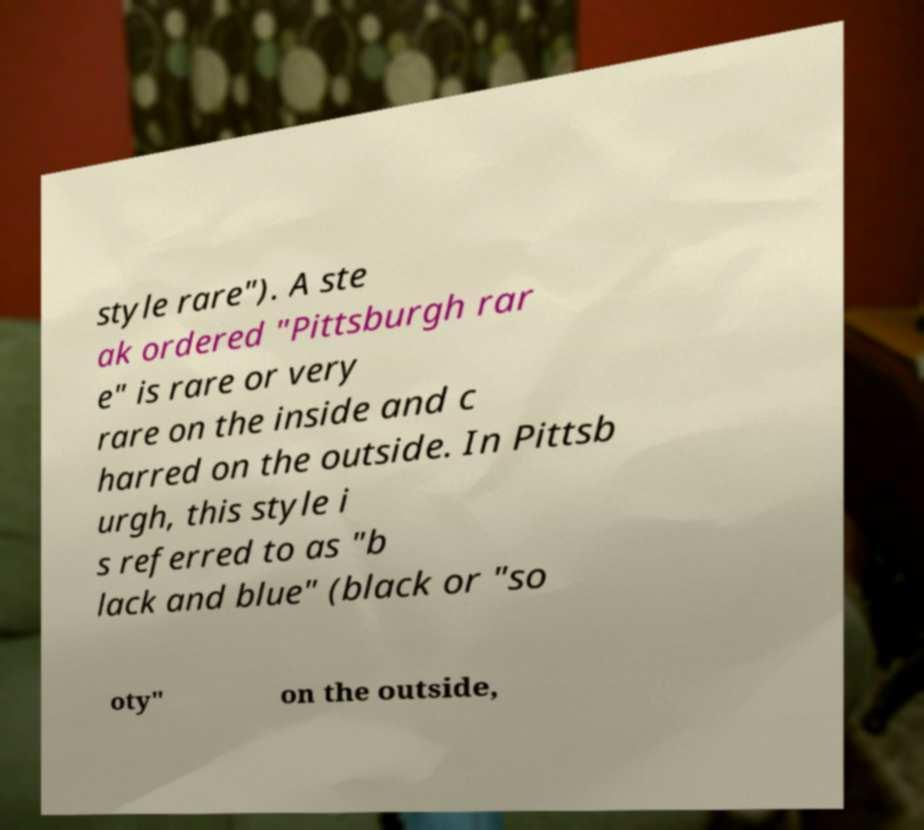Please read and relay the text visible in this image. What does it say? style rare"). A ste ak ordered "Pittsburgh rar e" is rare or very rare on the inside and c harred on the outside. In Pittsb urgh, this style i s referred to as "b lack and blue" (black or "so oty" on the outside, 